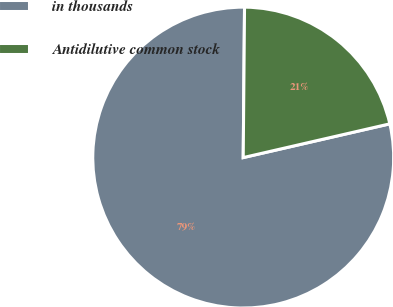Convert chart. <chart><loc_0><loc_0><loc_500><loc_500><pie_chart><fcel>in thousands<fcel>Antidilutive common stock<nl><fcel>78.74%<fcel>21.26%<nl></chart> 